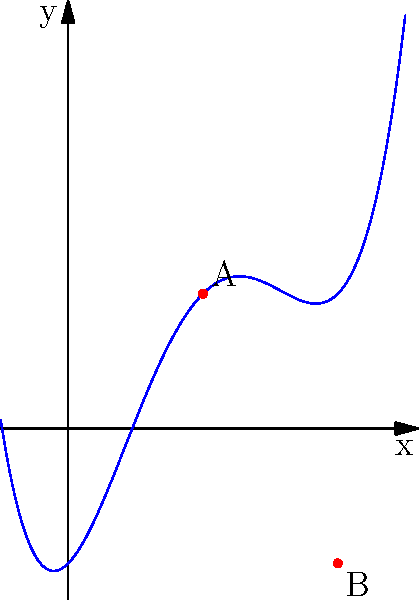Consider the polynomial function $f(x) = x^4 - 4x^3 + 4x^2 + x - 1$ depicted in the graph above. Points A and B represent the turning points of the function. In the context of optimal stopping problems, if this polynomial represents the expected payoff over time, what is the significance of point A, and how does it relate to the concept of stopping times in martingale theory? To answer this question, let's break it down step-by-step:

1) First, we need to understand what the turning points represent in this polynomial function. The turning points are where the function changes from increasing to decreasing or vice versa. They occur where the first derivative of the function equals zero.

2) Point A, being a local maximum, represents the highest expected payoff in the given interval.

3) In the context of optimal stopping problems, point A is significant because:

   a) It represents the optimal time to stop if we want to maximize the expected payoff.
   b) After this point, the expected payoff starts to decrease, making it less favorable to continue.

4) Relating this to martingale theory and stopping times:

   a) In martingale theory, a stopping time is a decision to stop based on the information available up to that time.
   b) The concept of optional stopping theorem in martingale theory states that under certain conditions, the expected value at a stopping time equals the initial expected value.

5) In this context, point A can be viewed as an optimal stopping time because:

   a) It maximizes the expected payoff.
   b) It's a predictable time based on the information of the process up to that point (i.e., the shape of the function before point A).

6) The significance of point A in relation to stopping times is that it represents the ideal balance between gathering information (waiting) and taking action (stopping). In martingale theory, this balance is crucial for developing optimal stopping strategies.
Answer: Point A represents the optimal stopping time, maximizing expected payoff and balancing information gathering with action in martingale-based stopping problems. 